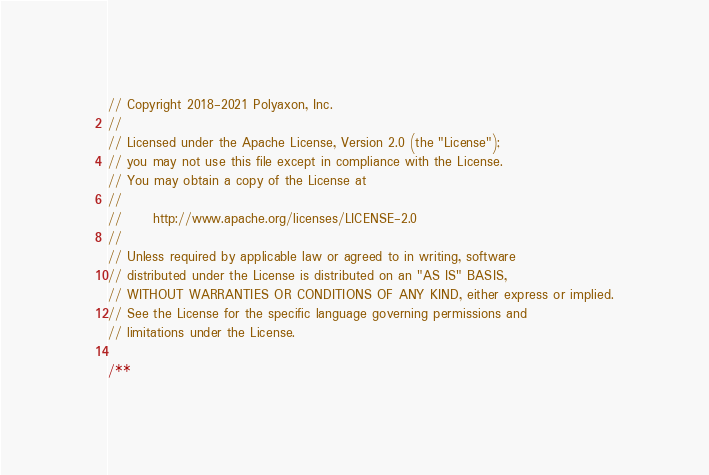Convert code to text. <code><loc_0><loc_0><loc_500><loc_500><_JavaScript_>// Copyright 2018-2021 Polyaxon, Inc.
//
// Licensed under the Apache License, Version 2.0 (the "License");
// you may not use this file except in compliance with the License.
// You may obtain a copy of the License at
//
//      http://www.apache.org/licenses/LICENSE-2.0
//
// Unless required by applicable law or agreed to in writing, software
// distributed under the License is distributed on an "AS IS" BASIS,
// WITHOUT WARRANTIES OR CONDITIONS OF ANY KIND, either express or implied.
// See the License for the specific language governing permissions and
// limitations under the License.

/**</code> 